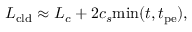Convert formula to latex. <formula><loc_0><loc_0><loc_500><loc_500>L _ { c l d } \approx L _ { c } + 2 c _ { s } \min ( t , t _ { p e } ) ,</formula> 